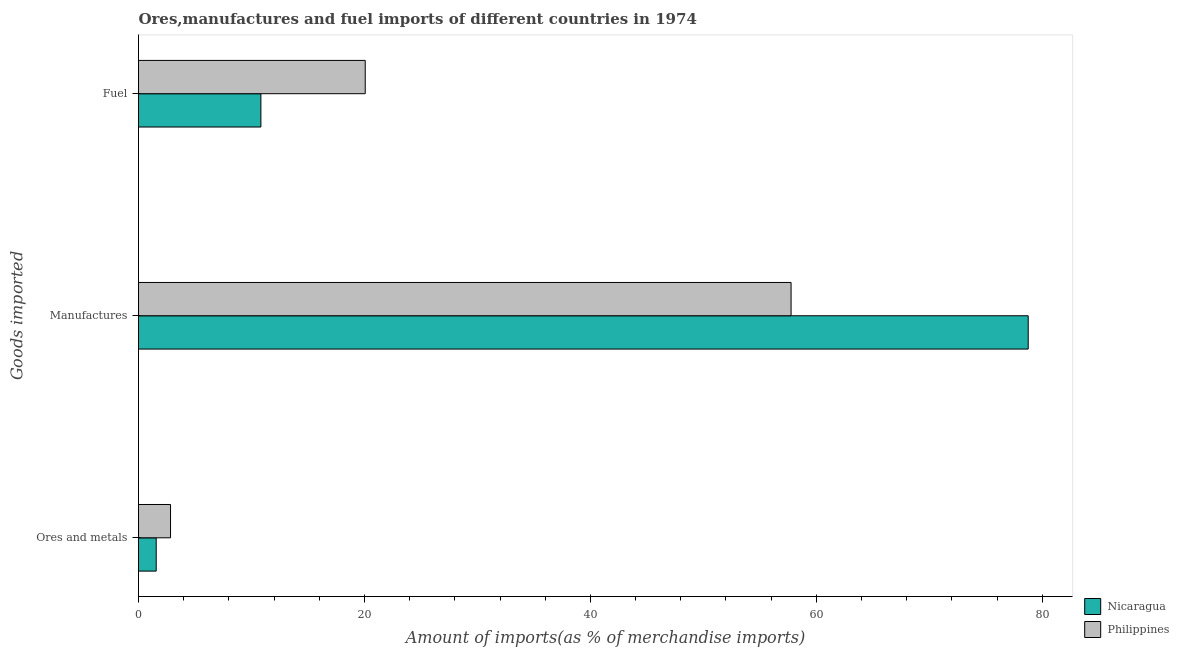How many groups of bars are there?
Give a very brief answer. 3. Are the number of bars per tick equal to the number of legend labels?
Give a very brief answer. Yes. Are the number of bars on each tick of the Y-axis equal?
Offer a terse response. Yes. How many bars are there on the 1st tick from the top?
Your response must be concise. 2. What is the label of the 3rd group of bars from the top?
Your answer should be very brief. Ores and metals. What is the percentage of ores and metals imports in Nicaragua?
Make the answer very short. 1.57. Across all countries, what is the maximum percentage of fuel imports?
Give a very brief answer. 20.07. Across all countries, what is the minimum percentage of manufactures imports?
Keep it short and to the point. 57.76. In which country was the percentage of fuel imports maximum?
Provide a succinct answer. Philippines. In which country was the percentage of ores and metals imports minimum?
Ensure brevity in your answer.  Nicaragua. What is the total percentage of ores and metals imports in the graph?
Offer a terse response. 4.4. What is the difference between the percentage of manufactures imports in Nicaragua and that in Philippines?
Ensure brevity in your answer.  20.99. What is the difference between the percentage of ores and metals imports in Philippines and the percentage of fuel imports in Nicaragua?
Give a very brief answer. -8. What is the average percentage of ores and metals imports per country?
Your answer should be very brief. 2.2. What is the difference between the percentage of fuel imports and percentage of manufactures imports in Philippines?
Ensure brevity in your answer.  -37.69. What is the ratio of the percentage of ores and metals imports in Nicaragua to that in Philippines?
Provide a succinct answer. 0.55. Is the difference between the percentage of manufactures imports in Nicaragua and Philippines greater than the difference between the percentage of ores and metals imports in Nicaragua and Philippines?
Provide a succinct answer. Yes. What is the difference between the highest and the second highest percentage of fuel imports?
Provide a succinct answer. 9.24. What is the difference between the highest and the lowest percentage of ores and metals imports?
Ensure brevity in your answer.  1.27. In how many countries, is the percentage of fuel imports greater than the average percentage of fuel imports taken over all countries?
Offer a very short reply. 1. Is the sum of the percentage of ores and metals imports in Nicaragua and Philippines greater than the maximum percentage of fuel imports across all countries?
Provide a succinct answer. No. What does the 1st bar from the top in Manufactures represents?
Your answer should be compact. Philippines. How many bars are there?
Give a very brief answer. 6. How many countries are there in the graph?
Your response must be concise. 2. Are the values on the major ticks of X-axis written in scientific E-notation?
Make the answer very short. No. Does the graph contain any zero values?
Keep it short and to the point. No. How are the legend labels stacked?
Offer a terse response. Vertical. What is the title of the graph?
Provide a succinct answer. Ores,manufactures and fuel imports of different countries in 1974. What is the label or title of the X-axis?
Ensure brevity in your answer.  Amount of imports(as % of merchandise imports). What is the label or title of the Y-axis?
Your answer should be very brief. Goods imported. What is the Amount of imports(as % of merchandise imports) in Nicaragua in Ores and metals?
Provide a succinct answer. 1.57. What is the Amount of imports(as % of merchandise imports) of Philippines in Ores and metals?
Offer a terse response. 2.83. What is the Amount of imports(as % of merchandise imports) in Nicaragua in Manufactures?
Give a very brief answer. 78.75. What is the Amount of imports(as % of merchandise imports) in Philippines in Manufactures?
Make the answer very short. 57.76. What is the Amount of imports(as % of merchandise imports) of Nicaragua in Fuel?
Ensure brevity in your answer.  10.83. What is the Amount of imports(as % of merchandise imports) in Philippines in Fuel?
Offer a very short reply. 20.07. Across all Goods imported, what is the maximum Amount of imports(as % of merchandise imports) in Nicaragua?
Give a very brief answer. 78.75. Across all Goods imported, what is the maximum Amount of imports(as % of merchandise imports) of Philippines?
Keep it short and to the point. 57.76. Across all Goods imported, what is the minimum Amount of imports(as % of merchandise imports) in Nicaragua?
Your answer should be very brief. 1.57. Across all Goods imported, what is the minimum Amount of imports(as % of merchandise imports) of Philippines?
Keep it short and to the point. 2.83. What is the total Amount of imports(as % of merchandise imports) of Nicaragua in the graph?
Give a very brief answer. 91.15. What is the total Amount of imports(as % of merchandise imports) of Philippines in the graph?
Your answer should be very brief. 80.67. What is the difference between the Amount of imports(as % of merchandise imports) in Nicaragua in Ores and metals and that in Manufactures?
Offer a very short reply. -77.19. What is the difference between the Amount of imports(as % of merchandise imports) of Philippines in Ores and metals and that in Manufactures?
Offer a very short reply. -54.93. What is the difference between the Amount of imports(as % of merchandise imports) in Nicaragua in Ores and metals and that in Fuel?
Provide a succinct answer. -9.27. What is the difference between the Amount of imports(as % of merchandise imports) in Philippines in Ores and metals and that in Fuel?
Give a very brief answer. -17.24. What is the difference between the Amount of imports(as % of merchandise imports) of Nicaragua in Manufactures and that in Fuel?
Offer a very short reply. 67.92. What is the difference between the Amount of imports(as % of merchandise imports) in Philippines in Manufactures and that in Fuel?
Your answer should be very brief. 37.69. What is the difference between the Amount of imports(as % of merchandise imports) of Nicaragua in Ores and metals and the Amount of imports(as % of merchandise imports) of Philippines in Manufactures?
Make the answer very short. -56.2. What is the difference between the Amount of imports(as % of merchandise imports) in Nicaragua in Ores and metals and the Amount of imports(as % of merchandise imports) in Philippines in Fuel?
Your answer should be compact. -18.5. What is the difference between the Amount of imports(as % of merchandise imports) in Nicaragua in Manufactures and the Amount of imports(as % of merchandise imports) in Philippines in Fuel?
Your response must be concise. 58.68. What is the average Amount of imports(as % of merchandise imports) of Nicaragua per Goods imported?
Your answer should be very brief. 30.38. What is the average Amount of imports(as % of merchandise imports) of Philippines per Goods imported?
Give a very brief answer. 26.89. What is the difference between the Amount of imports(as % of merchandise imports) in Nicaragua and Amount of imports(as % of merchandise imports) in Philippines in Ores and metals?
Your answer should be compact. -1.27. What is the difference between the Amount of imports(as % of merchandise imports) of Nicaragua and Amount of imports(as % of merchandise imports) of Philippines in Manufactures?
Offer a terse response. 20.99. What is the difference between the Amount of imports(as % of merchandise imports) in Nicaragua and Amount of imports(as % of merchandise imports) in Philippines in Fuel?
Your response must be concise. -9.24. What is the ratio of the Amount of imports(as % of merchandise imports) of Nicaragua in Ores and metals to that in Manufactures?
Keep it short and to the point. 0.02. What is the ratio of the Amount of imports(as % of merchandise imports) in Philippines in Ores and metals to that in Manufactures?
Offer a very short reply. 0.05. What is the ratio of the Amount of imports(as % of merchandise imports) of Nicaragua in Ores and metals to that in Fuel?
Offer a terse response. 0.14. What is the ratio of the Amount of imports(as % of merchandise imports) in Philippines in Ores and metals to that in Fuel?
Provide a short and direct response. 0.14. What is the ratio of the Amount of imports(as % of merchandise imports) in Nicaragua in Manufactures to that in Fuel?
Your answer should be compact. 7.27. What is the ratio of the Amount of imports(as % of merchandise imports) of Philippines in Manufactures to that in Fuel?
Your response must be concise. 2.88. What is the difference between the highest and the second highest Amount of imports(as % of merchandise imports) in Nicaragua?
Your answer should be very brief. 67.92. What is the difference between the highest and the second highest Amount of imports(as % of merchandise imports) in Philippines?
Provide a short and direct response. 37.69. What is the difference between the highest and the lowest Amount of imports(as % of merchandise imports) of Nicaragua?
Provide a succinct answer. 77.19. What is the difference between the highest and the lowest Amount of imports(as % of merchandise imports) in Philippines?
Your answer should be compact. 54.93. 